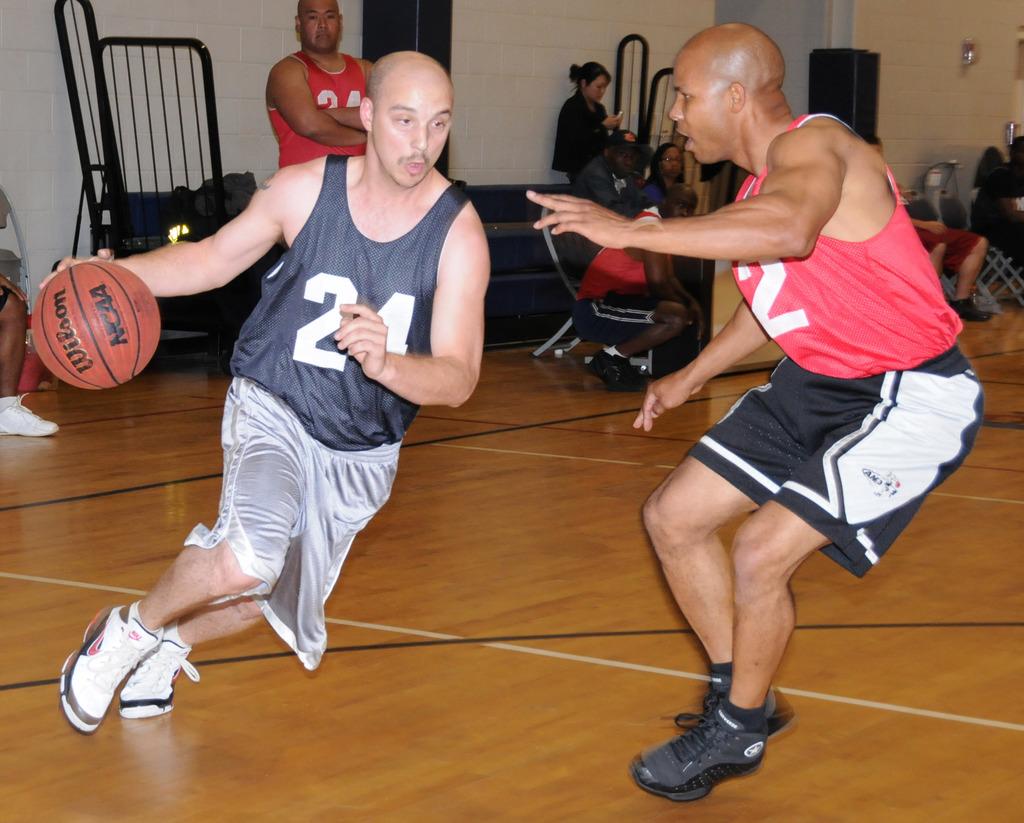What is the player's number?
Keep it short and to the point. 24. 